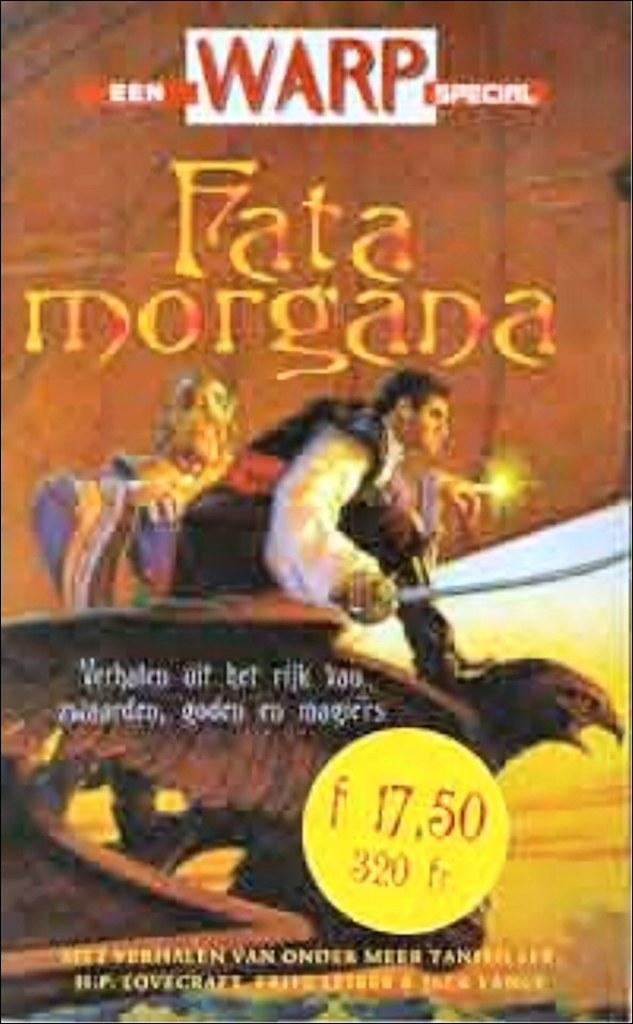What is the main subject of the image? There is an advertisement in the image. Can you describe the advertisement? Unfortunately, the provided facts do not include any details about the advertisement. However, we can confirm that it is the main subject of the image. What type of metal is the goose made of in the image? There is no goose present in the image, and therefore no metal goose to describe. 